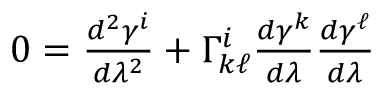Convert formula to latex. <formula><loc_0><loc_0><loc_500><loc_500>\begin{array} { r } { 0 = \frac { d ^ { 2 } \gamma ^ { i } } { d \lambda ^ { 2 } } + \Gamma _ { k \ell } ^ { i } \frac { d \gamma ^ { k } } { d \lambda } \frac { d \gamma ^ { \ell } } { d \lambda } } \end{array}</formula> 